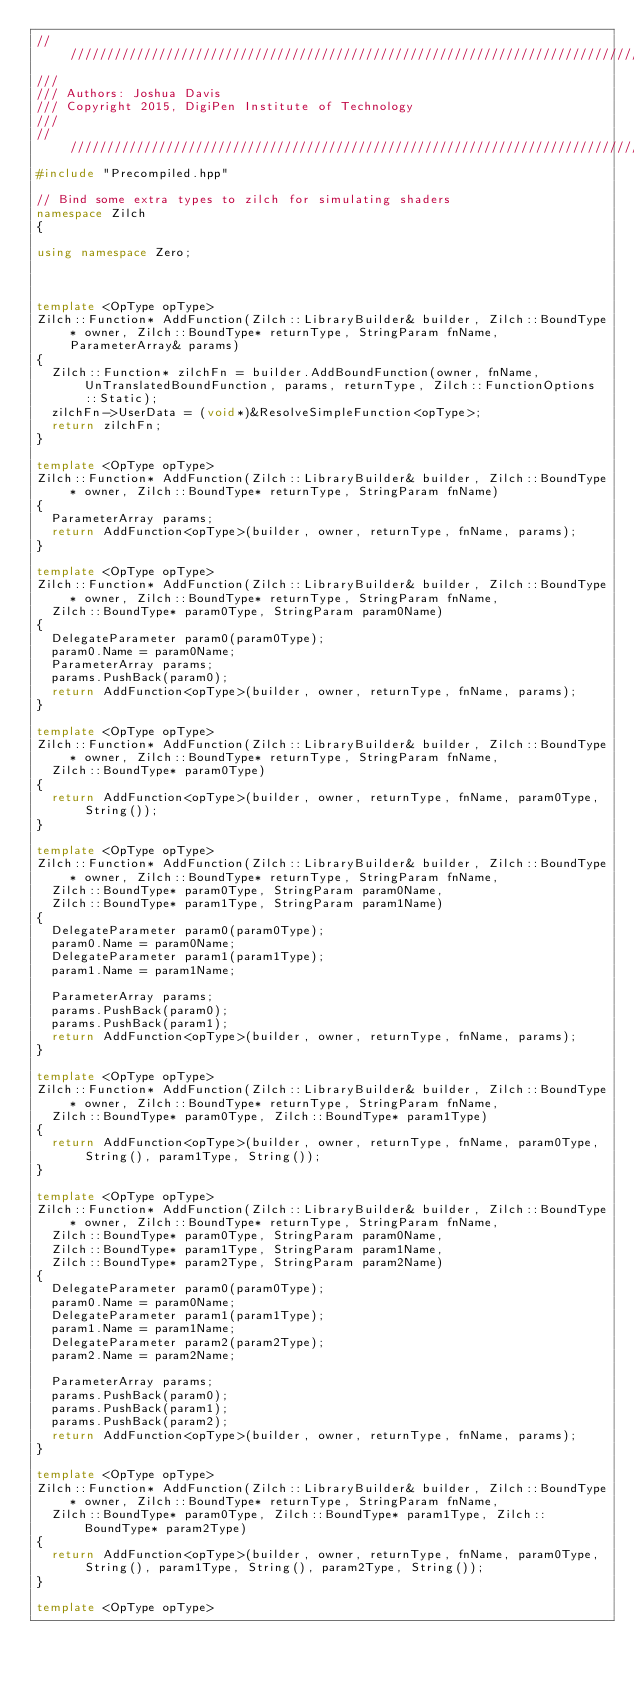<code> <loc_0><loc_0><loc_500><loc_500><_C++_>///////////////////////////////////////////////////////////////////////////////
///
/// Authors: Joshua Davis
/// Copyright 2015, DigiPen Institute of Technology
///
///////////////////////////////////////////////////////////////////////////////
#include "Precompiled.hpp"

// Bind some extra types to zilch for simulating shaders
namespace Zilch
{

using namespace Zero;



template <OpType opType>
Zilch::Function* AddFunction(Zilch::LibraryBuilder& builder, Zilch::BoundType* owner, Zilch::BoundType* returnType, StringParam fnName, ParameterArray& params)
{
  Zilch::Function* zilchFn = builder.AddBoundFunction(owner, fnName, UnTranslatedBoundFunction, params, returnType, Zilch::FunctionOptions::Static);
  zilchFn->UserData = (void*)&ResolveSimpleFunction<opType>;
  return zilchFn;
}

template <OpType opType>
Zilch::Function* AddFunction(Zilch::LibraryBuilder& builder, Zilch::BoundType* owner, Zilch::BoundType* returnType, StringParam fnName)
{
  ParameterArray params;
  return AddFunction<opType>(builder, owner, returnType, fnName, params);
}

template <OpType opType>
Zilch::Function* AddFunction(Zilch::LibraryBuilder& builder, Zilch::BoundType* owner, Zilch::BoundType* returnType, StringParam fnName,
  Zilch::BoundType* param0Type, StringParam param0Name)
{
  DelegateParameter param0(param0Type);
  param0.Name = param0Name;
  ParameterArray params;
  params.PushBack(param0);
  return AddFunction<opType>(builder, owner, returnType, fnName, params);
}

template <OpType opType>
Zilch::Function* AddFunction(Zilch::LibraryBuilder& builder, Zilch::BoundType* owner, Zilch::BoundType* returnType, StringParam fnName,
  Zilch::BoundType* param0Type)
{
  return AddFunction<opType>(builder, owner, returnType, fnName, param0Type, String());
}

template <OpType opType>
Zilch::Function* AddFunction(Zilch::LibraryBuilder& builder, Zilch::BoundType* owner, Zilch::BoundType* returnType, StringParam fnName,
  Zilch::BoundType* param0Type, StringParam param0Name,
  Zilch::BoundType* param1Type, StringParam param1Name)
{
  DelegateParameter param0(param0Type);
  param0.Name = param0Name;
  DelegateParameter param1(param1Type);
  param1.Name = param1Name;

  ParameterArray params;
  params.PushBack(param0);
  params.PushBack(param1);
  return AddFunction<opType>(builder, owner, returnType, fnName, params);
}

template <OpType opType>
Zilch::Function* AddFunction(Zilch::LibraryBuilder& builder, Zilch::BoundType* owner, Zilch::BoundType* returnType, StringParam fnName,
  Zilch::BoundType* param0Type, Zilch::BoundType* param1Type)
{
  return AddFunction<opType>(builder, owner, returnType, fnName, param0Type, String(), param1Type, String());
}

template <OpType opType>
Zilch::Function* AddFunction(Zilch::LibraryBuilder& builder, Zilch::BoundType* owner, Zilch::BoundType* returnType, StringParam fnName,
  Zilch::BoundType* param0Type, StringParam param0Name,
  Zilch::BoundType* param1Type, StringParam param1Name,
  Zilch::BoundType* param2Type, StringParam param2Name)
{
  DelegateParameter param0(param0Type);
  param0.Name = param0Name;
  DelegateParameter param1(param1Type);
  param1.Name = param1Name;
  DelegateParameter param2(param2Type);
  param2.Name = param2Name;

  ParameterArray params;
  params.PushBack(param0);
  params.PushBack(param1);
  params.PushBack(param2);
  return AddFunction<opType>(builder, owner, returnType, fnName, params);
}

template <OpType opType>
Zilch::Function* AddFunction(Zilch::LibraryBuilder& builder, Zilch::BoundType* owner, Zilch::BoundType* returnType, StringParam fnName,
  Zilch::BoundType* param0Type, Zilch::BoundType* param1Type, Zilch::BoundType* param2Type)
{
  return AddFunction<opType>(builder, owner, returnType, fnName, param0Type, String(), param1Type, String(), param2Type, String());
}

template <OpType opType></code> 